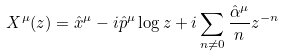Convert formula to latex. <formula><loc_0><loc_0><loc_500><loc_500>X ^ { \mu } ( z ) = \hat { x } ^ { \mu } - i \hat { p } ^ { \mu } \log z + i \sum _ { n \neq 0 } \frac { \hat { \alpha } ^ { \mu } } { n } z ^ { - n }</formula> 